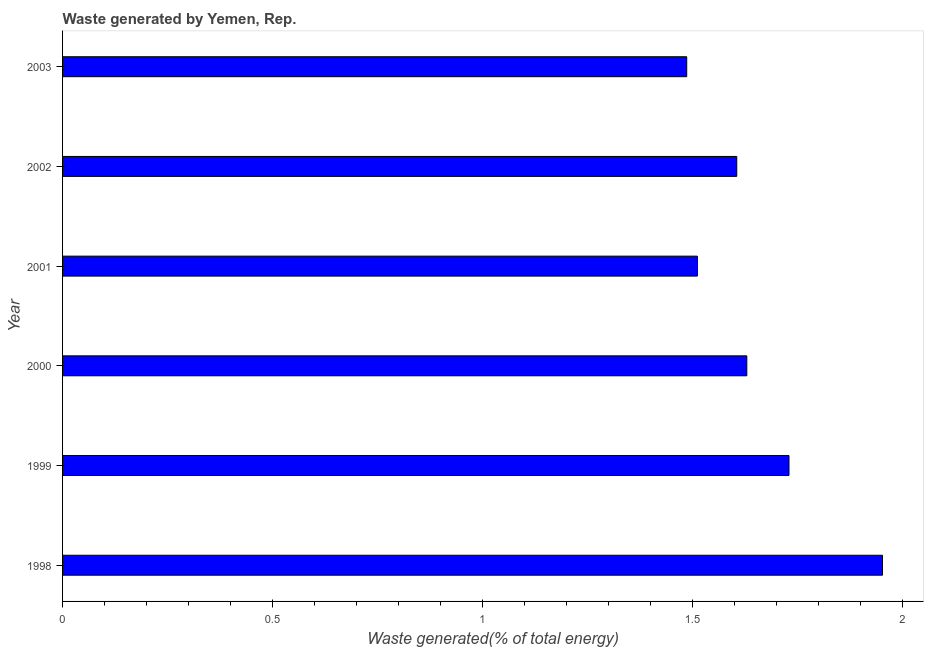What is the title of the graph?
Your answer should be very brief. Waste generated by Yemen, Rep. What is the label or title of the X-axis?
Keep it short and to the point. Waste generated(% of total energy). What is the label or title of the Y-axis?
Make the answer very short. Year. What is the amount of waste generated in 1998?
Give a very brief answer. 1.95. Across all years, what is the maximum amount of waste generated?
Your answer should be very brief. 1.95. Across all years, what is the minimum amount of waste generated?
Offer a very short reply. 1.49. What is the sum of the amount of waste generated?
Your response must be concise. 9.92. What is the difference between the amount of waste generated in 2000 and 2003?
Your answer should be very brief. 0.14. What is the average amount of waste generated per year?
Give a very brief answer. 1.65. What is the median amount of waste generated?
Offer a terse response. 1.62. In how many years, is the amount of waste generated greater than 1 %?
Your answer should be very brief. 6. Do a majority of the years between 1999 and 1998 (inclusive) have amount of waste generated greater than 1.4 %?
Ensure brevity in your answer.  No. What is the ratio of the amount of waste generated in 1999 to that in 2002?
Provide a succinct answer. 1.08. Is the difference between the amount of waste generated in 2000 and 2001 greater than the difference between any two years?
Your response must be concise. No. What is the difference between the highest and the second highest amount of waste generated?
Provide a succinct answer. 0.22. Is the sum of the amount of waste generated in 2001 and 2003 greater than the maximum amount of waste generated across all years?
Keep it short and to the point. Yes. What is the difference between the highest and the lowest amount of waste generated?
Provide a succinct answer. 0.47. Are the values on the major ticks of X-axis written in scientific E-notation?
Your answer should be compact. No. What is the Waste generated(% of total energy) of 1998?
Provide a short and direct response. 1.95. What is the Waste generated(% of total energy) of 1999?
Your answer should be compact. 1.73. What is the Waste generated(% of total energy) in 2000?
Provide a short and direct response. 1.63. What is the Waste generated(% of total energy) of 2001?
Offer a very short reply. 1.51. What is the Waste generated(% of total energy) of 2002?
Offer a terse response. 1.61. What is the Waste generated(% of total energy) of 2003?
Offer a terse response. 1.49. What is the difference between the Waste generated(% of total energy) in 1998 and 1999?
Your response must be concise. 0.22. What is the difference between the Waste generated(% of total energy) in 1998 and 2000?
Keep it short and to the point. 0.32. What is the difference between the Waste generated(% of total energy) in 1998 and 2001?
Offer a terse response. 0.44. What is the difference between the Waste generated(% of total energy) in 1998 and 2002?
Your answer should be compact. 0.35. What is the difference between the Waste generated(% of total energy) in 1998 and 2003?
Make the answer very short. 0.47. What is the difference between the Waste generated(% of total energy) in 1999 and 2000?
Offer a terse response. 0.1. What is the difference between the Waste generated(% of total energy) in 1999 and 2001?
Your answer should be compact. 0.22. What is the difference between the Waste generated(% of total energy) in 1999 and 2002?
Offer a very short reply. 0.12. What is the difference between the Waste generated(% of total energy) in 1999 and 2003?
Provide a succinct answer. 0.24. What is the difference between the Waste generated(% of total energy) in 2000 and 2001?
Ensure brevity in your answer.  0.12. What is the difference between the Waste generated(% of total energy) in 2000 and 2002?
Keep it short and to the point. 0.02. What is the difference between the Waste generated(% of total energy) in 2000 and 2003?
Provide a short and direct response. 0.14. What is the difference between the Waste generated(% of total energy) in 2001 and 2002?
Provide a short and direct response. -0.09. What is the difference between the Waste generated(% of total energy) in 2001 and 2003?
Provide a short and direct response. 0.03. What is the difference between the Waste generated(% of total energy) in 2002 and 2003?
Keep it short and to the point. 0.12. What is the ratio of the Waste generated(% of total energy) in 1998 to that in 1999?
Make the answer very short. 1.13. What is the ratio of the Waste generated(% of total energy) in 1998 to that in 2000?
Your answer should be compact. 1.2. What is the ratio of the Waste generated(% of total energy) in 1998 to that in 2001?
Keep it short and to the point. 1.29. What is the ratio of the Waste generated(% of total energy) in 1998 to that in 2002?
Provide a succinct answer. 1.22. What is the ratio of the Waste generated(% of total energy) in 1998 to that in 2003?
Keep it short and to the point. 1.31. What is the ratio of the Waste generated(% of total energy) in 1999 to that in 2000?
Ensure brevity in your answer.  1.06. What is the ratio of the Waste generated(% of total energy) in 1999 to that in 2001?
Ensure brevity in your answer.  1.14. What is the ratio of the Waste generated(% of total energy) in 1999 to that in 2002?
Provide a short and direct response. 1.08. What is the ratio of the Waste generated(% of total energy) in 1999 to that in 2003?
Provide a short and direct response. 1.16. What is the ratio of the Waste generated(% of total energy) in 2000 to that in 2001?
Give a very brief answer. 1.08. What is the ratio of the Waste generated(% of total energy) in 2000 to that in 2003?
Provide a short and direct response. 1.1. What is the ratio of the Waste generated(% of total energy) in 2001 to that in 2002?
Make the answer very short. 0.94. What is the ratio of the Waste generated(% of total energy) in 2001 to that in 2003?
Provide a short and direct response. 1.02. 